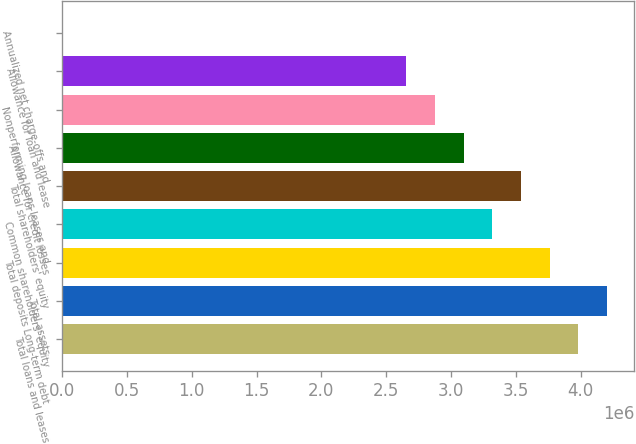Convert chart. <chart><loc_0><loc_0><loc_500><loc_500><bar_chart><fcel>Total loans and leases<fcel>Total assets<fcel>Total deposits Long-term debt<fcel>Common shareholders' equity<fcel>Total shareholders' equity<fcel>Allowance for credit losses<fcel>Nonperforming loans leases and<fcel>Allowance for loan and lease<fcel>Annualized net charge-offs and<nl><fcel>3.98237e+06<fcel>4.20362e+06<fcel>3.76113e+06<fcel>3.31864e+06<fcel>3.53989e+06<fcel>3.0974e+06<fcel>2.87616e+06<fcel>2.65492e+06<fcel>1.52<nl></chart> 